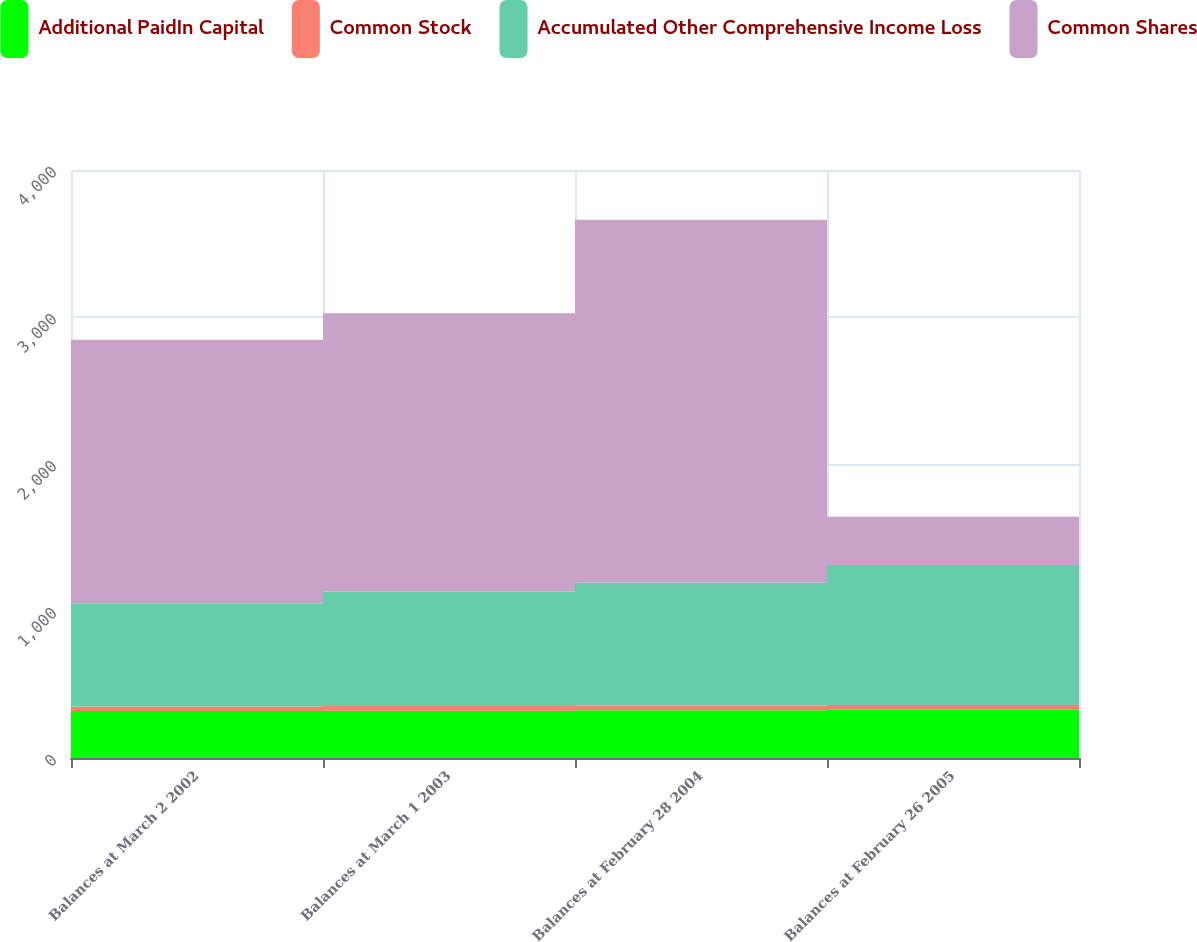<chart> <loc_0><loc_0><loc_500><loc_500><stacked_bar_chart><ecel><fcel>Balances at March 2 2002<fcel>Balances at March 1 2003<fcel>Balances at February 28 2004<fcel>Balances at February 26 2005<nl><fcel>Additional PaidIn Capital<fcel>319<fcel>322<fcel>325<fcel>328<nl><fcel>Common Stock<fcel>31<fcel>32<fcel>32<fcel>33<nl><fcel>Accumulated Other Comprehensive Income Loss<fcel>702<fcel>778<fcel>836<fcel>952<nl><fcel>Common Shares<fcel>1794<fcel>1893<fcel>2468<fcel>328<nl></chart> 